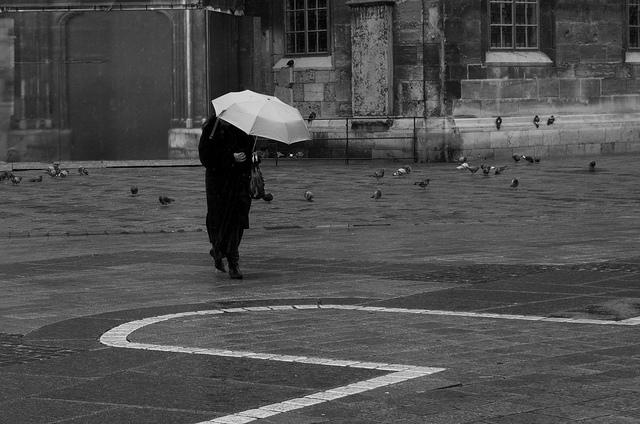What is the person hiding behind?

Choices:
A) umbrella
B) car
C) apple
D) box umbrella 